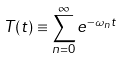Convert formula to latex. <formula><loc_0><loc_0><loc_500><loc_500>T ( t ) \equiv \sum _ { n = 0 } ^ { \infty } e ^ { - \omega _ { n } t }</formula> 